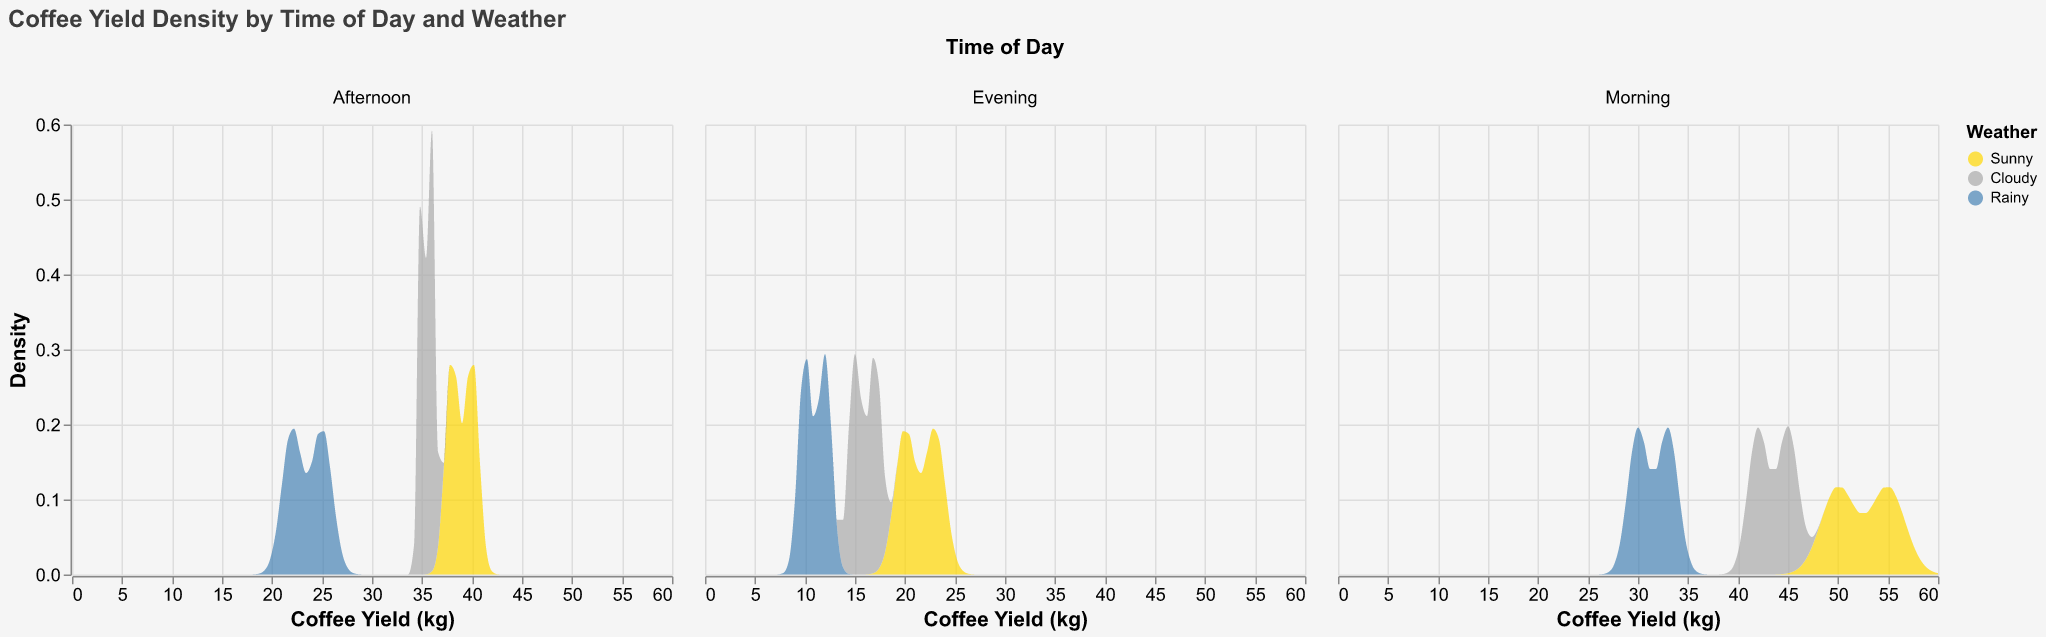What is the title of the figure? The title of the figure is located at the top and in bold font. It says "Coffee Yield Density by Time of Day and Weather".
Answer: Coffee Yield Density by Time of Day and Weather What are the three weather conditions represented in the figure? The weather conditions are indicated by the legend, which uses different colors for each condition. The three weather conditions are Sunny, Cloudy, and Rainy.
Answer: Sunny, Cloudy, Rainy In which time of day and weather condition do we see the highest coffee yield density? Examine the density plot peaks within each section for Morning, Afternoon, and Evening, and look at different colors representing weather conditions. The highest coffee yield density is during Morning in Sunny weather conditions.
Answer: Morning, Sunny How does the coffee yield density for Cloudy conditions vary from Morning to Evening? Trace the density plots for Cloudy weather across the Morning, Afternoon, and Evening sections and compare their shapes and density values. Coffee yield density for Cloudy conditions is highest in the Morning, decreases in the Afternoon, and is lowest in the Evening.
Answer: Decreases from Morning to Evening What is the range of coffee yields displayed on the x-axis? The range of coffee yields is shown on the x-axis. Here, it spans from 0 kg to 60 kg.
Answer: 0 kg to 60 kg Considering the density plots, which weather condition consistently shows the lowest coffee yield densities? Analyze the density plots across all times of the day and identify which color, representing the weather condition, consistently shows the lowest densities. Rainy conditions (blue color) show the lowest coffee yield densities consistently.
Answer: Rainy Between Morning and Afternoon, which time of day has a higher coffee yield density for Sunny weather? Compare the density curves for Sunny weather in the Morning and Afternoon sections by looking at their peak values and areas under the curves. Morning has a higher coffee yield density for Sunny weather compared to Afternoon.
Answer: Morning What is the color used to represent Rainy weather in the density plot? The legend matches weather conditions to colors shown in the density plot. Rainy weather is represented by a blue color.
Answer: Blue How do density values for coffee yield in the Evening compare between Sunny and Rainy conditions? In the Evening section, compare the density plots for Sunny (gold color) and Rainy (blue color) conditions by observing the height and area under the curves. Sunny conditions have higher density values compared to Rainy conditions in the Evening.
Answer: Sunny conditions have higher density values During Afternoon, which weather condition shows the broadest spread in coffee yield density? In the Afternoon section, examine the spread of the density plots for each weather condition by looking at the width of the curves on the x-axis. Cloudy conditions show the broadest spread in coffee yield density during the Afternoon.
Answer: Cloudy 